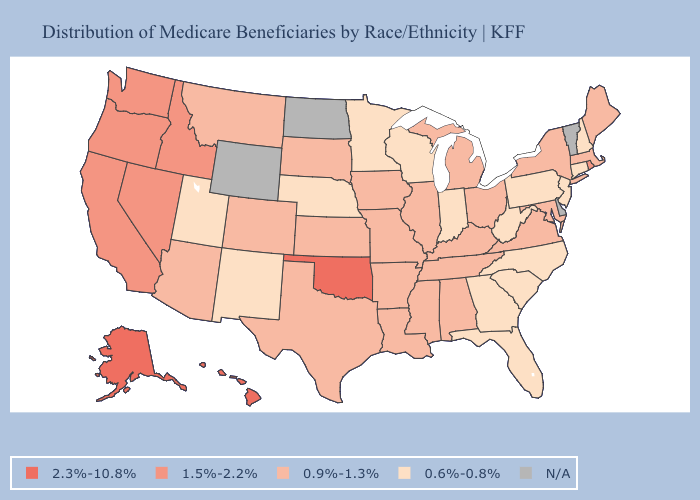What is the lowest value in states that border New Mexico?
Give a very brief answer. 0.6%-0.8%. What is the lowest value in states that border Minnesota?
Be succinct. 0.6%-0.8%. Among the states that border Kansas , does Colorado have the lowest value?
Answer briefly. No. What is the value of Pennsylvania?
Short answer required. 0.6%-0.8%. What is the lowest value in the USA?
Write a very short answer. 0.6%-0.8%. How many symbols are there in the legend?
Keep it brief. 5. What is the value of Pennsylvania?
Quick response, please. 0.6%-0.8%. What is the highest value in states that border Kentucky?
Concise answer only. 0.9%-1.3%. How many symbols are there in the legend?
Concise answer only. 5. Among the states that border Kansas , does Oklahoma have the highest value?
Keep it brief. Yes. Among the states that border Illinois , which have the lowest value?
Keep it brief. Indiana, Wisconsin. What is the value of Idaho?
Quick response, please. 1.5%-2.2%. Does Indiana have the lowest value in the MidWest?
Short answer required. Yes. Name the states that have a value in the range 0.9%-1.3%?
Short answer required. Alabama, Arizona, Arkansas, Colorado, Illinois, Iowa, Kansas, Kentucky, Louisiana, Maine, Maryland, Massachusetts, Michigan, Mississippi, Missouri, Montana, New York, Ohio, South Dakota, Tennessee, Texas, Virginia. 